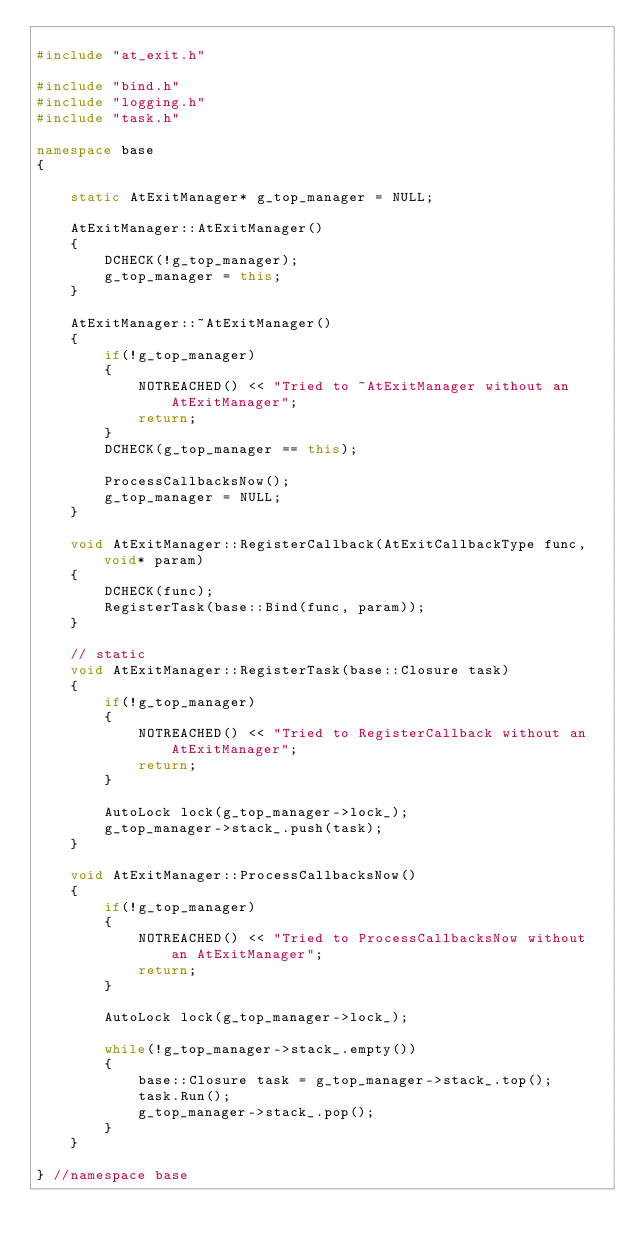Convert code to text. <code><loc_0><loc_0><loc_500><loc_500><_C++_>
#include "at_exit.h"

#include "bind.h"
#include "logging.h"
#include "task.h"

namespace base
{

    static AtExitManager* g_top_manager = NULL;

    AtExitManager::AtExitManager()
    {
        DCHECK(!g_top_manager);
        g_top_manager = this;
    }

    AtExitManager::~AtExitManager()
    {
        if(!g_top_manager)
        {
            NOTREACHED() << "Tried to ~AtExitManager without an AtExitManager";
            return;
        }
        DCHECK(g_top_manager == this);

        ProcessCallbacksNow();
        g_top_manager = NULL;
    }

    void AtExitManager::RegisterCallback(AtExitCallbackType func, void* param)
    {
        DCHECK(func);
        RegisterTask(base::Bind(func, param));
    }

    // static
    void AtExitManager::RegisterTask(base::Closure task)
    {
        if(!g_top_manager)
        {
            NOTREACHED() << "Tried to RegisterCallback without an AtExitManager";
            return;
        }

        AutoLock lock(g_top_manager->lock_);
        g_top_manager->stack_.push(task);
    }

    void AtExitManager::ProcessCallbacksNow()
    {
        if(!g_top_manager)
        {
            NOTREACHED() << "Tried to ProcessCallbacksNow without an AtExitManager";
            return;
        }

        AutoLock lock(g_top_manager->lock_);

        while(!g_top_manager->stack_.empty())
        {
            base::Closure task = g_top_manager->stack_.top();
            task.Run();
            g_top_manager->stack_.pop();
        }
    }

} //namespace base</code> 